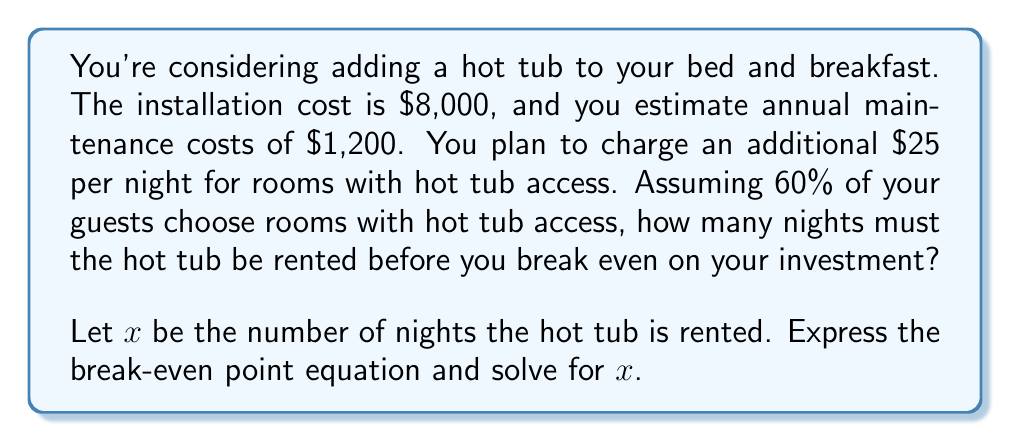What is the answer to this math problem? To solve this problem, we'll follow these steps:

1) First, let's identify our variables:
   - Fixed cost (FC) = $8,000 (installation cost)
   - Variable cost per year (VC) = $1,200 (annual maintenance)
   - Price (P) = $25 per night
   - $x$ = number of nights rented

2) The break-even point occurs when Total Revenue equals Total Cost:

   $$ \text{Total Revenue} = \text{Total Cost} $$
   $$ Px = FC + VC $$

3) Substitute the known values:

   $$ 25x = 8000 + 1200 $$

4) Simplify the right side:

   $$ 25x = 9200 $$

5) Solve for $x$ by dividing both sides by 25:

   $$ x = \frac{9200}{25} = 368 $$

6) However, remember that only 60% of guests choose rooms with hot tub access. To account for this, we need to divide our result by 0.6:

   $$ \text{Total nights needed} = \frac{368}{0.6} = 613.33 $$

7) Since we can't rent for a partial night, we round up to the nearest whole number.

Therefore, the hot tub needs to be rented for 614 nights before breaking even on the investment.
Answer: 614 nights 